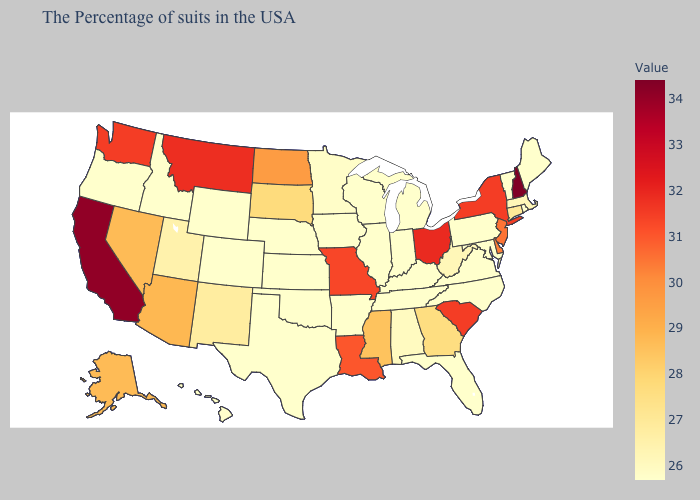Among the states that border Massachusetts , does Connecticut have the lowest value?
Short answer required. No. Among the states that border Vermont , does New Hampshire have the lowest value?
Be succinct. No. Does Maine have the lowest value in the Northeast?
Short answer required. Yes. Does Connecticut have the lowest value in the Northeast?
Concise answer only. No. 